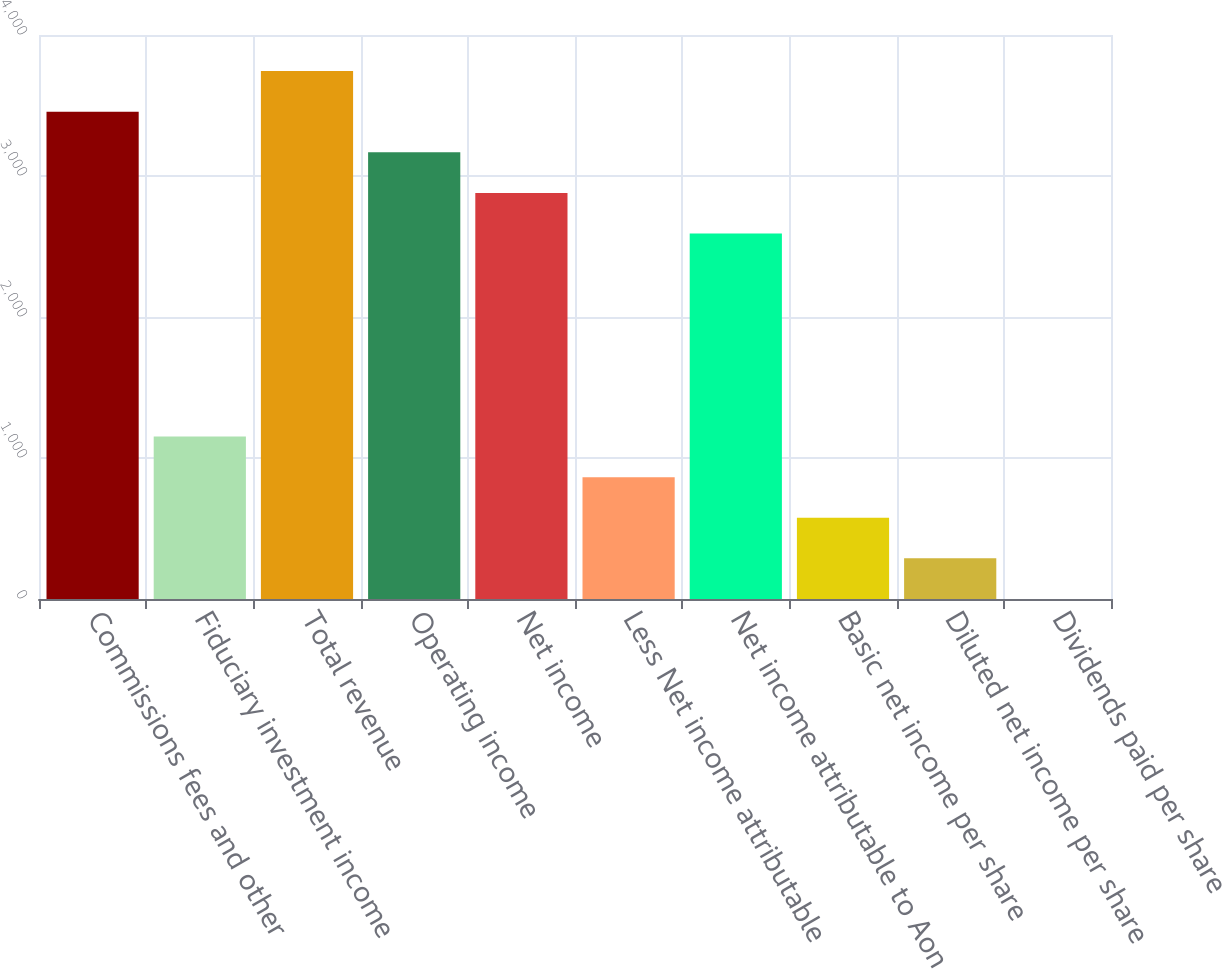Convert chart to OTSL. <chart><loc_0><loc_0><loc_500><loc_500><bar_chart><fcel>Commissions fees and other<fcel>Fiduciary investment income<fcel>Total revenue<fcel>Operating income<fcel>Net income<fcel>Less Net income attributable<fcel>Net income attributable to Aon<fcel>Basic net income per share<fcel>Diluted net income per share<fcel>Dividends paid per share<nl><fcel>3455.99<fcel>1152.16<fcel>3743.96<fcel>3168.01<fcel>2880.03<fcel>864.19<fcel>2592.05<fcel>576.21<fcel>288.23<fcel>0.25<nl></chart> 